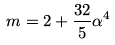<formula> <loc_0><loc_0><loc_500><loc_500>m = 2 + \frac { 3 2 } { 5 } \alpha ^ { 4 }</formula> 